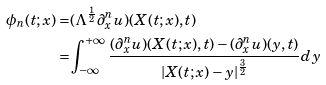<formula> <loc_0><loc_0><loc_500><loc_500>\phi _ { n } ( t ; x ) = & ( \Lambda ^ { \frac { 1 } { 2 } } \partial _ { x } ^ { n } u ) ( X ( t ; x ) , t ) \\ = & \int _ { - \infty } ^ { + \infty } \frac { ( \partial _ { x } ^ { n } u ) ( X ( t ; x ) , t ) - ( \partial _ { x } ^ { n } u ) ( y , t ) } { | X ( t ; x ) - y | ^ { \frac { 3 } { 2 } } } d y</formula> 